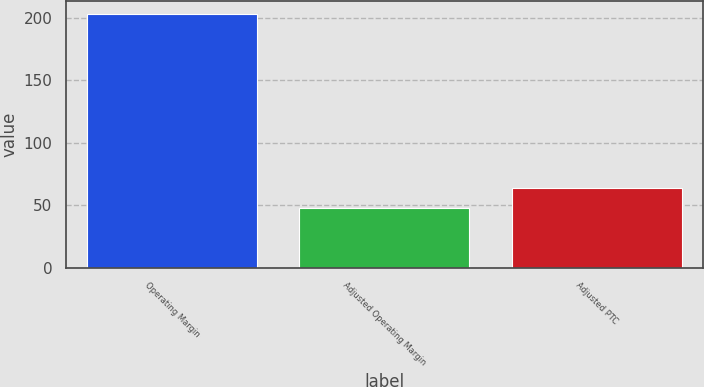Convert chart. <chart><loc_0><loc_0><loc_500><loc_500><bar_chart><fcel>Operating Margin<fcel>Adjusted Operating Margin<fcel>Adjusted PTC<nl><fcel>203<fcel>48<fcel>63.5<nl></chart> 